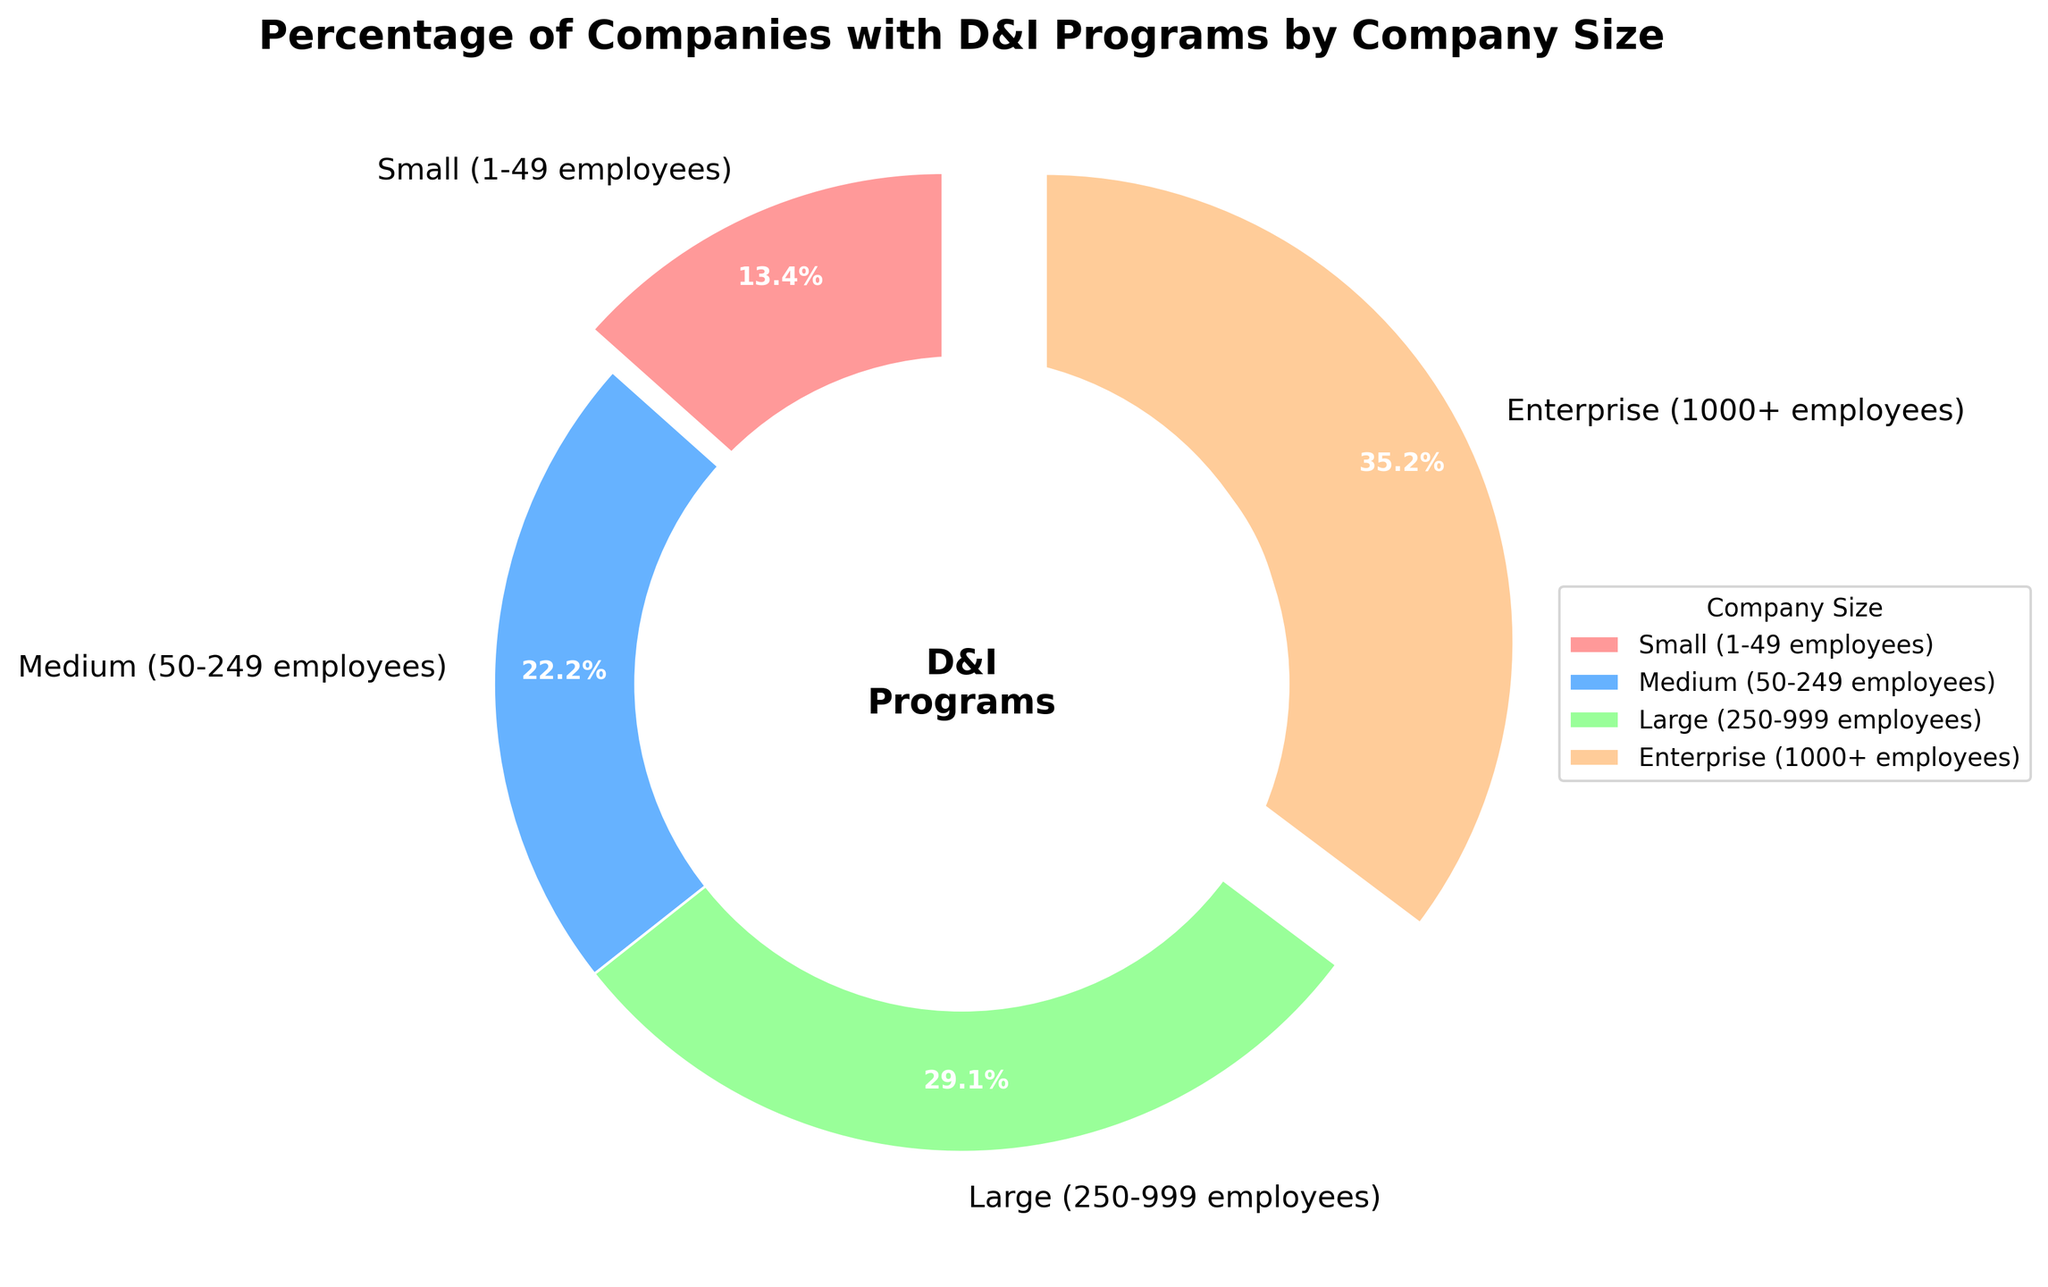What is the percentage of small companies with diversity and inclusion (D&I) programs? First, identify the label "Small (1-49 employees)" in the pie chart. Then, read the percentage value associated with it, which is displayed within or next to the wedge.
Answer: 35% Which company size has the highest percentage of D&I programs? Look at the pie chart and find the wedge with the largest percentage value. The label connected to this wedge provides the answer.
Answer: Enterprise (1000+ employees) How much higher is the percentage of medium-sized companies with D&I programs compared to small companies? First, find the percentages of medium-sized and small companies with D&I programs in the pie chart. Subtract the smaller percentage (35% for small companies) from the larger percentage (58% for medium-sized companies).
Answer: 23% What is the difference in the percentage of companies with D&I programs between large and enterprise-sized companies? Identify the percentages for large and enterprise-sized companies from the pie chart. Subtract the percentage for large companies (76%) from the percentage for enterprise-sized companies (92%).
Answer: 16% Which wedge in the pie chart has the second smallest percentage? Review the labels and percentages on the pie chart. The wedge with the second smallest percentage is the one associated with the medium (50-249 employees) category, which is higher than the smallest (35%) and smaller than the higher two.
Answer: Medium (50-249 employees) What is the percentage of companies with D&I programs in the two largest size categories combined? Add the percentages of large companies (76%) and enterprise-sized companies (92%) from the pie chart.
Answer: 168% What color represents medium-sized companies in the pie chart? Locate the wedge for medium-sized companies (50-249 employees) in the pie chart and note its color.
Answer: Blue How much more likely is it for an enterprise-sized company to have a D&I program compared to a small company? Divide the percentage of enterprise-sized companies with D&I programs (92%) by the percentage of small companies (35%) and then express it as a ratio or a comparison statement.
Answer: Approximately 2.63 times more likely Which two company sizes have a difference in their D&I program percentages that add up to the sum of percentages of small companies' D&I programs? Identify the percentages of the wedges and find two company sizes whose percentage difference equals 35%. The two sizes are enterprise (92%) and large (76%) since 92% - 76% = 16%, which is not suitable. Try enterprise (92%) and medium (58%). 92 - 58 = 34%.
Answer: No two suitable sizes found 